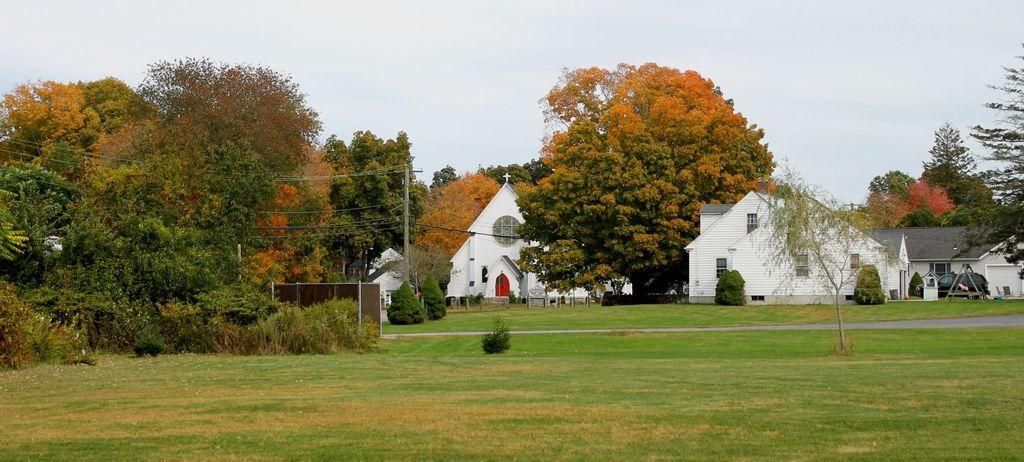Can you describe this image briefly? In this image there is the ground. There is grass on the ground. In the center there is a path. In the background there are houses and a cathedral. There are trees, plants and poles in the image. There is a vehicle parked in front of the house. At the top there is the sky. 